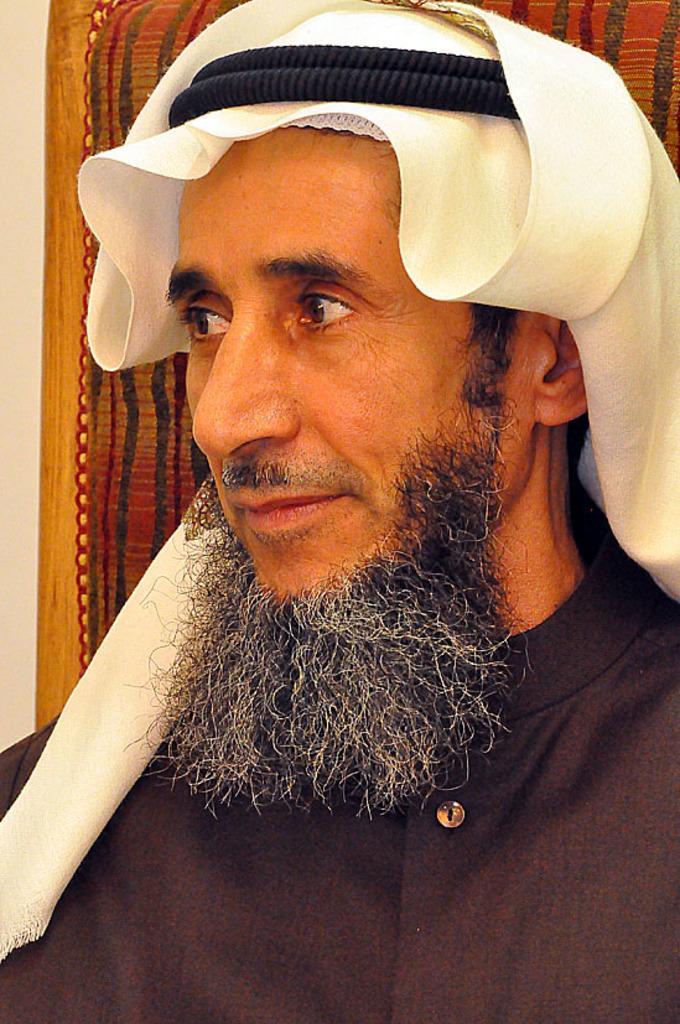In one or two sentences, can you explain what this image depicts? In this picture we can see a person with the "Arab turban". Behind the person, it looks like a chair and the wall. 